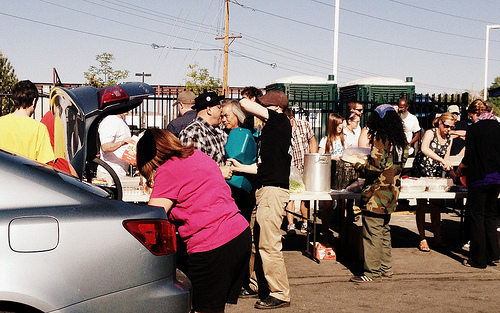<image>
Is there a car in front of the woman? Yes. The car is positioned in front of the woman, appearing closer to the camera viewpoint. 